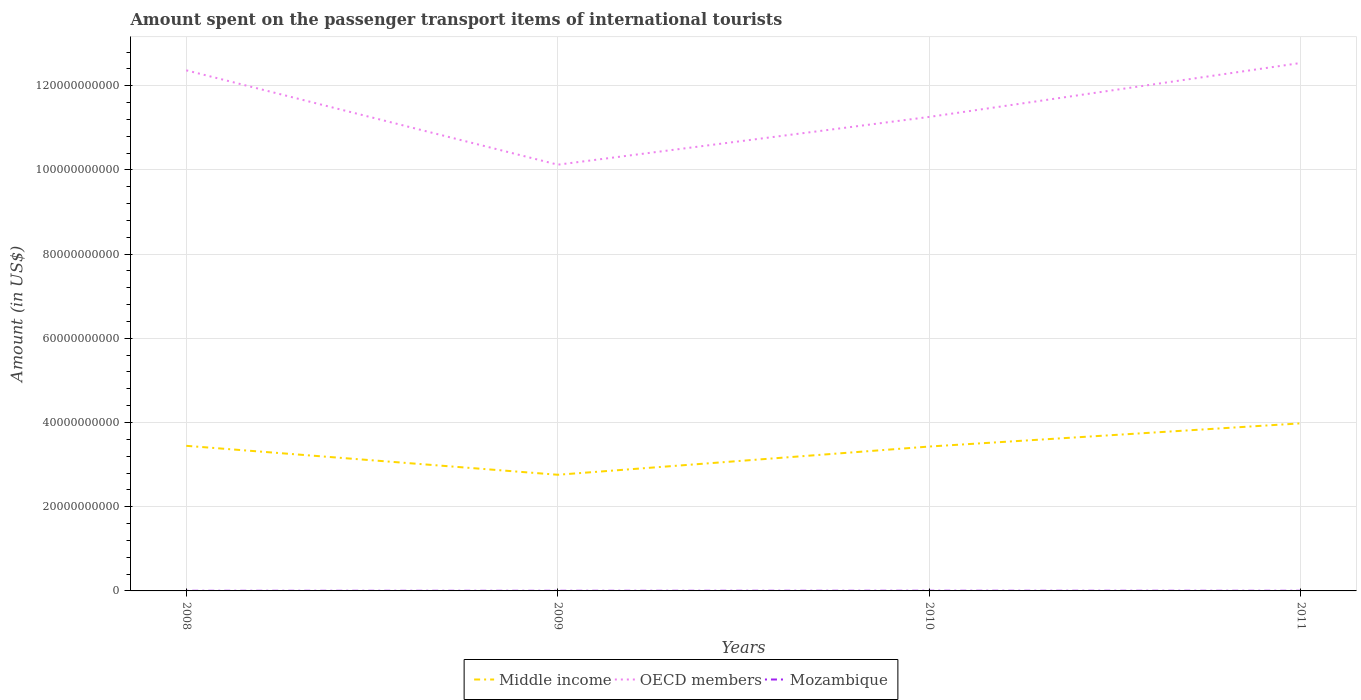How many different coloured lines are there?
Offer a terse response. 3. Is the number of lines equal to the number of legend labels?
Offer a very short reply. Yes. Across all years, what is the maximum amount spent on the passenger transport items of international tourists in Mozambique?
Offer a very short reply. 3.30e+07. What is the total amount spent on the passenger transport items of international tourists in Middle income in the graph?
Your response must be concise. -5.34e+09. What is the difference between the highest and the second highest amount spent on the passenger transport items of international tourists in Middle income?
Offer a terse response. 1.22e+1. Is the amount spent on the passenger transport items of international tourists in OECD members strictly greater than the amount spent on the passenger transport items of international tourists in Middle income over the years?
Provide a short and direct response. No. How many lines are there?
Make the answer very short. 3. Does the graph contain any zero values?
Ensure brevity in your answer.  No. Does the graph contain grids?
Your answer should be compact. Yes. How are the legend labels stacked?
Offer a terse response. Horizontal. What is the title of the graph?
Give a very brief answer. Amount spent on the passenger transport items of international tourists. Does "Sudan" appear as one of the legend labels in the graph?
Your answer should be compact. No. What is the Amount (in US$) in Middle income in 2008?
Provide a short and direct response. 3.45e+1. What is the Amount (in US$) of OECD members in 2008?
Your answer should be compact. 1.24e+11. What is the Amount (in US$) in Mozambique in 2008?
Provide a short and direct response. 3.30e+07. What is the Amount (in US$) in Middle income in 2009?
Make the answer very short. 2.76e+1. What is the Amount (in US$) of OECD members in 2009?
Provide a succinct answer. 1.01e+11. What is the Amount (in US$) of Mozambique in 2009?
Ensure brevity in your answer.  3.50e+07. What is the Amount (in US$) of Middle income in 2010?
Make the answer very short. 3.43e+1. What is the Amount (in US$) in OECD members in 2010?
Your response must be concise. 1.13e+11. What is the Amount (in US$) of Mozambique in 2010?
Offer a terse response. 4.40e+07. What is the Amount (in US$) in Middle income in 2011?
Keep it short and to the point. 3.98e+1. What is the Amount (in US$) in OECD members in 2011?
Ensure brevity in your answer.  1.25e+11. What is the Amount (in US$) in Mozambique in 2011?
Give a very brief answer. 3.70e+07. Across all years, what is the maximum Amount (in US$) in Middle income?
Provide a succinct answer. 3.98e+1. Across all years, what is the maximum Amount (in US$) in OECD members?
Your response must be concise. 1.25e+11. Across all years, what is the maximum Amount (in US$) of Mozambique?
Your response must be concise. 4.40e+07. Across all years, what is the minimum Amount (in US$) in Middle income?
Your answer should be compact. 2.76e+1. Across all years, what is the minimum Amount (in US$) of OECD members?
Your response must be concise. 1.01e+11. Across all years, what is the minimum Amount (in US$) of Mozambique?
Your answer should be very brief. 3.30e+07. What is the total Amount (in US$) in Middle income in the graph?
Your answer should be compact. 1.36e+11. What is the total Amount (in US$) of OECD members in the graph?
Your answer should be very brief. 4.63e+11. What is the total Amount (in US$) in Mozambique in the graph?
Your response must be concise. 1.49e+08. What is the difference between the Amount (in US$) in Middle income in 2008 and that in 2009?
Make the answer very short. 6.87e+09. What is the difference between the Amount (in US$) of OECD members in 2008 and that in 2009?
Offer a terse response. 2.24e+1. What is the difference between the Amount (in US$) in Middle income in 2008 and that in 2010?
Your answer should be compact. 1.70e+08. What is the difference between the Amount (in US$) of OECD members in 2008 and that in 2010?
Your response must be concise. 1.11e+1. What is the difference between the Amount (in US$) of Mozambique in 2008 and that in 2010?
Provide a short and direct response. -1.10e+07. What is the difference between the Amount (in US$) of Middle income in 2008 and that in 2011?
Give a very brief answer. -5.34e+09. What is the difference between the Amount (in US$) of OECD members in 2008 and that in 2011?
Provide a succinct answer. -1.75e+09. What is the difference between the Amount (in US$) in Mozambique in 2008 and that in 2011?
Your response must be concise. -4.00e+06. What is the difference between the Amount (in US$) of Middle income in 2009 and that in 2010?
Your response must be concise. -6.70e+09. What is the difference between the Amount (in US$) in OECD members in 2009 and that in 2010?
Ensure brevity in your answer.  -1.13e+1. What is the difference between the Amount (in US$) in Mozambique in 2009 and that in 2010?
Provide a succinct answer. -9.00e+06. What is the difference between the Amount (in US$) of Middle income in 2009 and that in 2011?
Your response must be concise. -1.22e+1. What is the difference between the Amount (in US$) of OECD members in 2009 and that in 2011?
Your answer should be very brief. -2.42e+1. What is the difference between the Amount (in US$) of Middle income in 2010 and that in 2011?
Make the answer very short. -5.51e+09. What is the difference between the Amount (in US$) of OECD members in 2010 and that in 2011?
Offer a terse response. -1.28e+1. What is the difference between the Amount (in US$) of Middle income in 2008 and the Amount (in US$) of OECD members in 2009?
Keep it short and to the point. -6.68e+1. What is the difference between the Amount (in US$) of Middle income in 2008 and the Amount (in US$) of Mozambique in 2009?
Your answer should be compact. 3.44e+1. What is the difference between the Amount (in US$) of OECD members in 2008 and the Amount (in US$) of Mozambique in 2009?
Offer a very short reply. 1.24e+11. What is the difference between the Amount (in US$) in Middle income in 2008 and the Amount (in US$) in OECD members in 2010?
Ensure brevity in your answer.  -7.81e+1. What is the difference between the Amount (in US$) in Middle income in 2008 and the Amount (in US$) in Mozambique in 2010?
Ensure brevity in your answer.  3.44e+1. What is the difference between the Amount (in US$) of OECD members in 2008 and the Amount (in US$) of Mozambique in 2010?
Ensure brevity in your answer.  1.24e+11. What is the difference between the Amount (in US$) of Middle income in 2008 and the Amount (in US$) of OECD members in 2011?
Your answer should be very brief. -9.09e+1. What is the difference between the Amount (in US$) of Middle income in 2008 and the Amount (in US$) of Mozambique in 2011?
Your response must be concise. 3.44e+1. What is the difference between the Amount (in US$) of OECD members in 2008 and the Amount (in US$) of Mozambique in 2011?
Your response must be concise. 1.24e+11. What is the difference between the Amount (in US$) of Middle income in 2009 and the Amount (in US$) of OECD members in 2010?
Give a very brief answer. -8.50e+1. What is the difference between the Amount (in US$) of Middle income in 2009 and the Amount (in US$) of Mozambique in 2010?
Your answer should be compact. 2.75e+1. What is the difference between the Amount (in US$) of OECD members in 2009 and the Amount (in US$) of Mozambique in 2010?
Provide a short and direct response. 1.01e+11. What is the difference between the Amount (in US$) in Middle income in 2009 and the Amount (in US$) in OECD members in 2011?
Offer a very short reply. -9.78e+1. What is the difference between the Amount (in US$) of Middle income in 2009 and the Amount (in US$) of Mozambique in 2011?
Offer a terse response. 2.76e+1. What is the difference between the Amount (in US$) in OECD members in 2009 and the Amount (in US$) in Mozambique in 2011?
Provide a succinct answer. 1.01e+11. What is the difference between the Amount (in US$) in Middle income in 2010 and the Amount (in US$) in OECD members in 2011?
Give a very brief answer. -9.11e+1. What is the difference between the Amount (in US$) in Middle income in 2010 and the Amount (in US$) in Mozambique in 2011?
Your answer should be very brief. 3.43e+1. What is the difference between the Amount (in US$) in OECD members in 2010 and the Amount (in US$) in Mozambique in 2011?
Your answer should be compact. 1.13e+11. What is the average Amount (in US$) of Middle income per year?
Ensure brevity in your answer.  3.40e+1. What is the average Amount (in US$) in OECD members per year?
Provide a succinct answer. 1.16e+11. What is the average Amount (in US$) of Mozambique per year?
Your response must be concise. 3.72e+07. In the year 2008, what is the difference between the Amount (in US$) of Middle income and Amount (in US$) of OECD members?
Your answer should be very brief. -8.92e+1. In the year 2008, what is the difference between the Amount (in US$) of Middle income and Amount (in US$) of Mozambique?
Your response must be concise. 3.44e+1. In the year 2008, what is the difference between the Amount (in US$) of OECD members and Amount (in US$) of Mozambique?
Provide a short and direct response. 1.24e+11. In the year 2009, what is the difference between the Amount (in US$) of Middle income and Amount (in US$) of OECD members?
Your answer should be compact. -7.36e+1. In the year 2009, what is the difference between the Amount (in US$) of Middle income and Amount (in US$) of Mozambique?
Make the answer very short. 2.76e+1. In the year 2009, what is the difference between the Amount (in US$) of OECD members and Amount (in US$) of Mozambique?
Provide a succinct answer. 1.01e+11. In the year 2010, what is the difference between the Amount (in US$) of Middle income and Amount (in US$) of OECD members?
Offer a terse response. -7.83e+1. In the year 2010, what is the difference between the Amount (in US$) of Middle income and Amount (in US$) of Mozambique?
Keep it short and to the point. 3.43e+1. In the year 2010, what is the difference between the Amount (in US$) in OECD members and Amount (in US$) in Mozambique?
Make the answer very short. 1.13e+11. In the year 2011, what is the difference between the Amount (in US$) in Middle income and Amount (in US$) in OECD members?
Provide a succinct answer. -8.56e+1. In the year 2011, what is the difference between the Amount (in US$) of Middle income and Amount (in US$) of Mozambique?
Provide a succinct answer. 3.98e+1. In the year 2011, what is the difference between the Amount (in US$) of OECD members and Amount (in US$) of Mozambique?
Ensure brevity in your answer.  1.25e+11. What is the ratio of the Amount (in US$) in Middle income in 2008 to that in 2009?
Your response must be concise. 1.25. What is the ratio of the Amount (in US$) of OECD members in 2008 to that in 2009?
Offer a terse response. 1.22. What is the ratio of the Amount (in US$) in Mozambique in 2008 to that in 2009?
Your answer should be very brief. 0.94. What is the ratio of the Amount (in US$) of OECD members in 2008 to that in 2010?
Your answer should be compact. 1.1. What is the ratio of the Amount (in US$) of Middle income in 2008 to that in 2011?
Make the answer very short. 0.87. What is the ratio of the Amount (in US$) of OECD members in 2008 to that in 2011?
Give a very brief answer. 0.99. What is the ratio of the Amount (in US$) in Mozambique in 2008 to that in 2011?
Keep it short and to the point. 0.89. What is the ratio of the Amount (in US$) in Middle income in 2009 to that in 2010?
Make the answer very short. 0.8. What is the ratio of the Amount (in US$) of OECD members in 2009 to that in 2010?
Make the answer very short. 0.9. What is the ratio of the Amount (in US$) in Mozambique in 2009 to that in 2010?
Ensure brevity in your answer.  0.8. What is the ratio of the Amount (in US$) of Middle income in 2009 to that in 2011?
Provide a short and direct response. 0.69. What is the ratio of the Amount (in US$) in OECD members in 2009 to that in 2011?
Provide a short and direct response. 0.81. What is the ratio of the Amount (in US$) in Mozambique in 2009 to that in 2011?
Ensure brevity in your answer.  0.95. What is the ratio of the Amount (in US$) in Middle income in 2010 to that in 2011?
Provide a short and direct response. 0.86. What is the ratio of the Amount (in US$) in OECD members in 2010 to that in 2011?
Your answer should be very brief. 0.9. What is the ratio of the Amount (in US$) in Mozambique in 2010 to that in 2011?
Keep it short and to the point. 1.19. What is the difference between the highest and the second highest Amount (in US$) in Middle income?
Provide a succinct answer. 5.34e+09. What is the difference between the highest and the second highest Amount (in US$) in OECD members?
Give a very brief answer. 1.75e+09. What is the difference between the highest and the lowest Amount (in US$) of Middle income?
Provide a short and direct response. 1.22e+1. What is the difference between the highest and the lowest Amount (in US$) in OECD members?
Make the answer very short. 2.42e+1. What is the difference between the highest and the lowest Amount (in US$) of Mozambique?
Provide a short and direct response. 1.10e+07. 